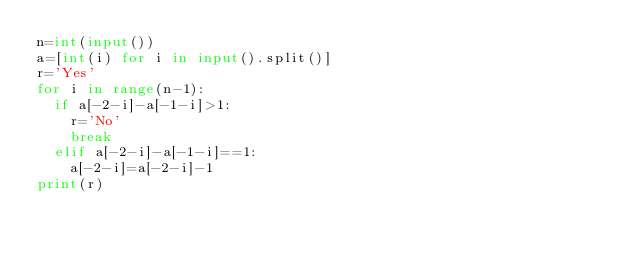<code> <loc_0><loc_0><loc_500><loc_500><_Python_>n=int(input())
a=[int(i) for i in input().split()]
r='Yes'
for i in range(n-1):
  if a[-2-i]-a[-1-i]>1:
    r='No'
    break
  elif a[-2-i]-a[-1-i]==1:
    a[-2-i]=a[-2-i]-1
print(r)    </code> 